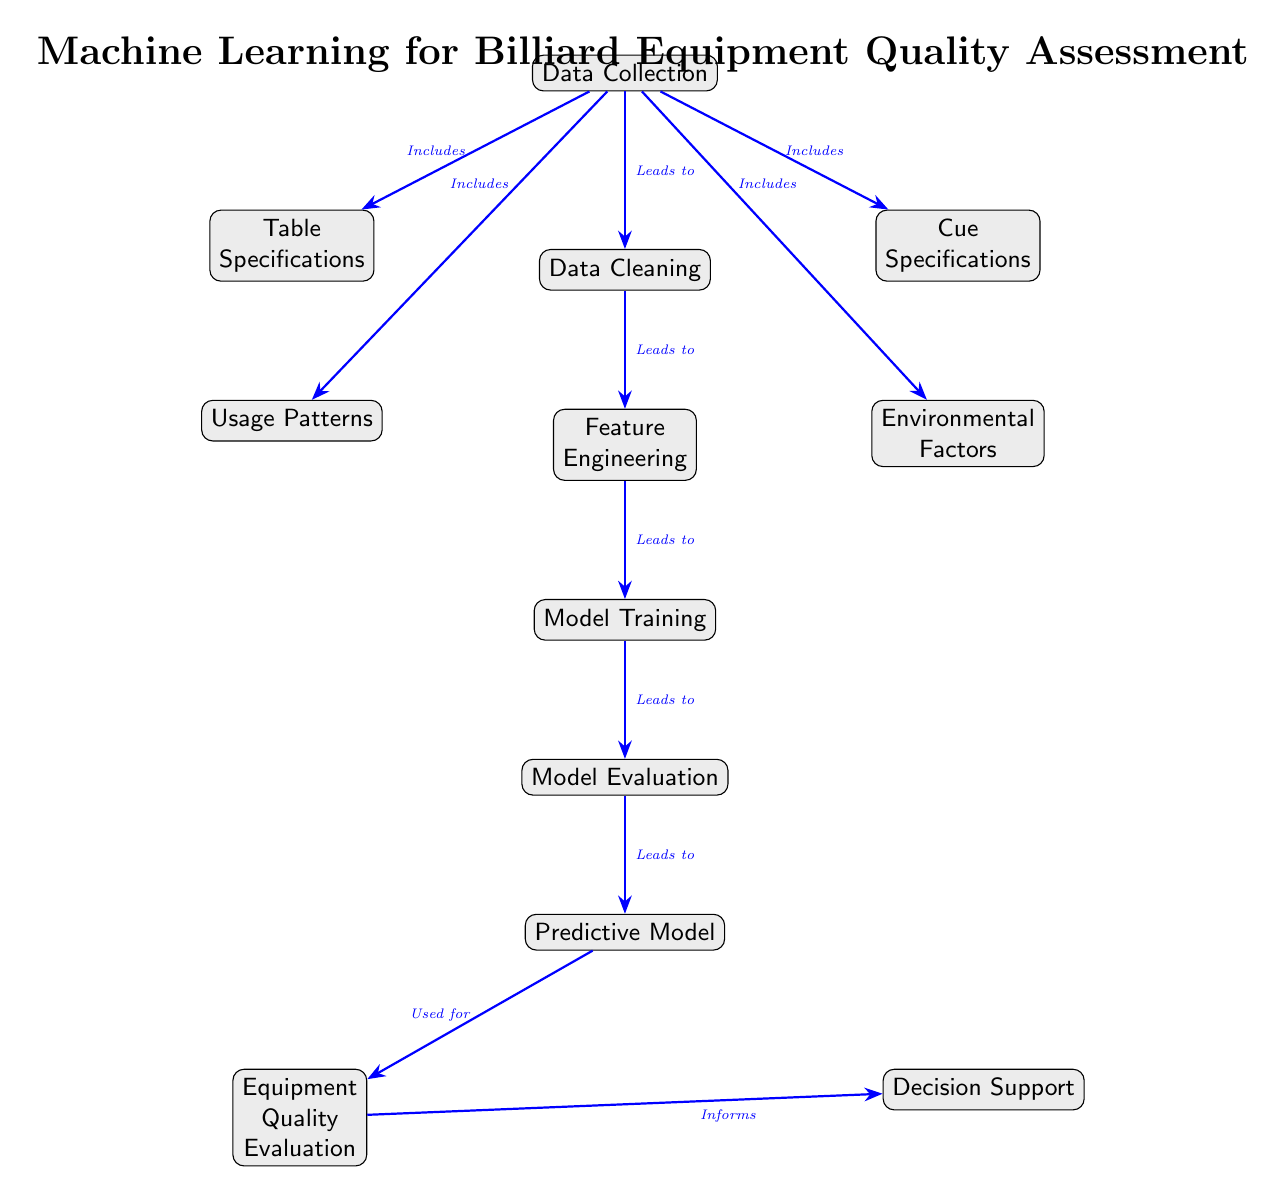Which node is at the top of the diagram? The node at the top of the diagram is "Data Collection," as it is the starting point of the flow in the diagram.
Answer: Data Collection How many main processes are listed in the diagram? There are a total of six main processes listed in the diagram: Data Collection, Data Cleaning, Feature Engineering, Model Training, Model Evaluation, and Equipment Quality Evaluation.
Answer: Six What does "Data Collection" include? "Data Collection" includes Table Specifications, Cue Specifications, Usage Patterns, and Environmental Factors, as indicated by the arrows branching from this node.
Answer: Table Specifications, Cue Specifications, Usage Patterns, Environmental Factors Which node directly follows "Feature Engineering"? "Model Training" directly follows "Feature Engineering," as indicated by the arrow leading from Feature Engineering to Model Training.
Answer: Model Training What informs "Decision Support"? "Equipment Quality Evaluation" informs "Decision Support," as shown by the arrow pointing from Equipment Quality Evaluation to Decision Support.
Answer: Equipment Quality Evaluation What is the relationship between "Model Evaluation" and "Predictive Model"? The relationship is that "Model Evaluation" leads to the "Predictive Model," indicating that evaluating the model is a necessary step to arrive at the predictive model.
Answer: Leads to Which node is used for predictive purposes? The "Predictive Model" node is used for predictive purposes, as indicated in the diagram. It is the central component post model evaluation leading to quality assessment.
Answer: Predictive Model What is the last step in this diagram? The last step in this diagram is "Decision Support," as it is the final node that receives input from the "Equipment Quality Evaluation."
Answer: Decision Support How many specifications do we collect data on? We collect data on two specifications: Table Specifications and Cue Specifications, as evident from the nodes branching off from "Data Collection."
Answer: Two 